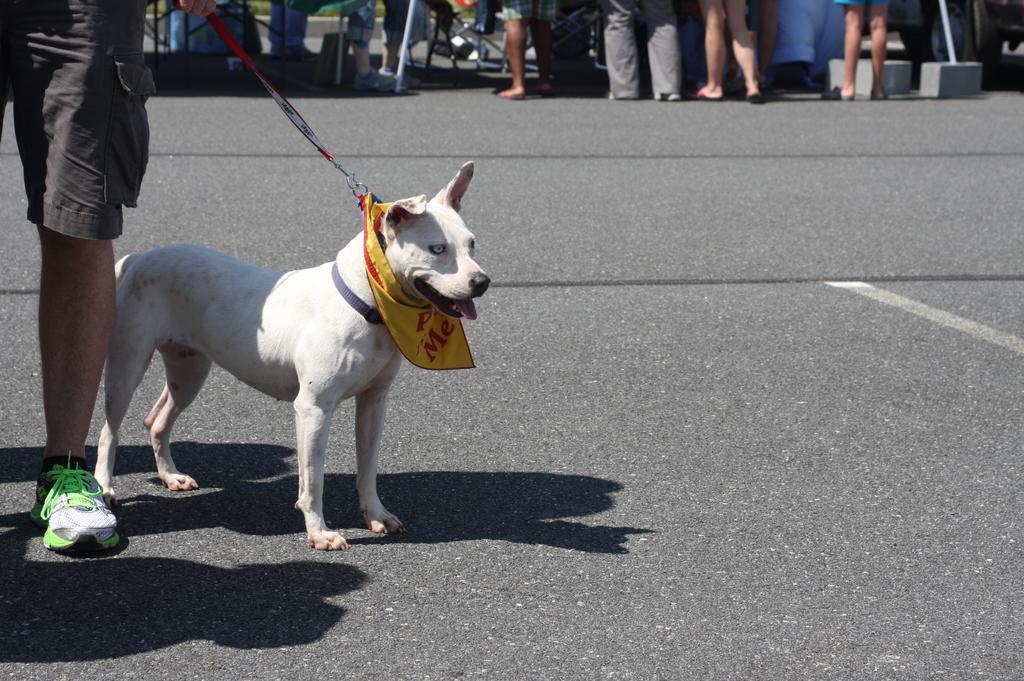Describe this image in one or two sentences. In this picture there is a person who is holding a dog with a leash. There is a yellow color cloth wrapped around the neck of a dog. He is standing on the road. There are few other people who are standing at the background. 